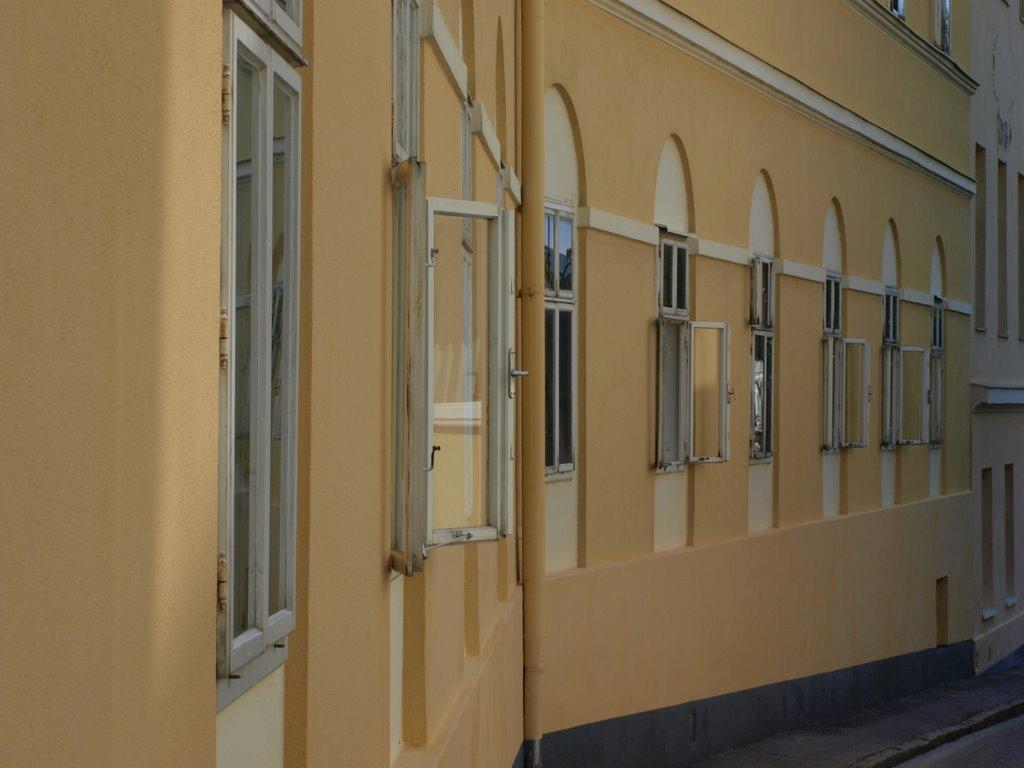What is the main subject of the image? The main subject of the image is a building. Can you describe the building in the center of the image? The building in the center of the image has windows. Are there any other buildings visible in the image? Yes, there is another building on the right side of the image. What role does the actor play in the image? There is no actor present in the image; it features buildings. What is the mass of the building on the right side of the image? The mass of the building cannot be determined from the image alone. 